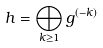<formula> <loc_0><loc_0><loc_500><loc_500>h = \bigoplus _ { k \geq 1 } g ^ { ( - k ) }</formula> 